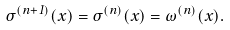Convert formula to latex. <formula><loc_0><loc_0><loc_500><loc_500>\sigma ^ { ( n + 1 ) } ( x ) = \sigma ^ { ( n ) } ( x ) = \omega ^ { ( n ) } ( x ) .</formula> 